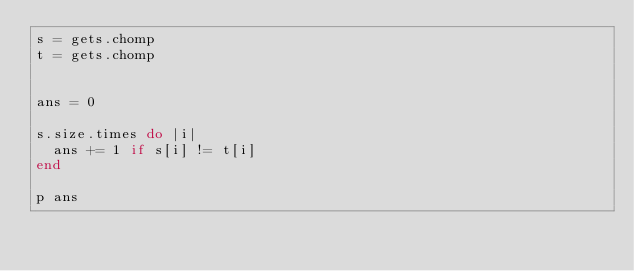<code> <loc_0><loc_0><loc_500><loc_500><_Ruby_>s = gets.chomp
t = gets.chomp


ans = 0

s.size.times do |i|
  ans += 1 if s[i] != t[i]
end

p ans</code> 